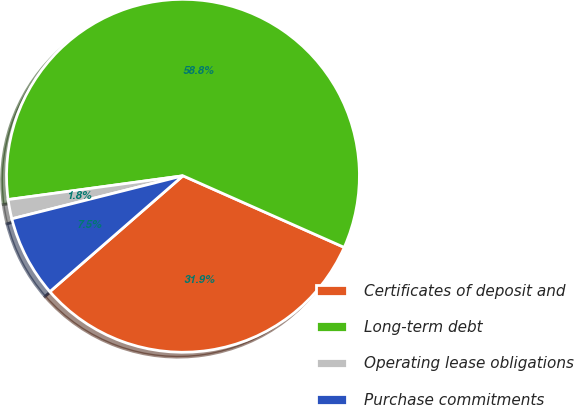<chart> <loc_0><loc_0><loc_500><loc_500><pie_chart><fcel>Certificates of deposit and<fcel>Long-term debt<fcel>Operating lease obligations<fcel>Purchase commitments<nl><fcel>31.95%<fcel>58.81%<fcel>1.77%<fcel>7.48%<nl></chart> 